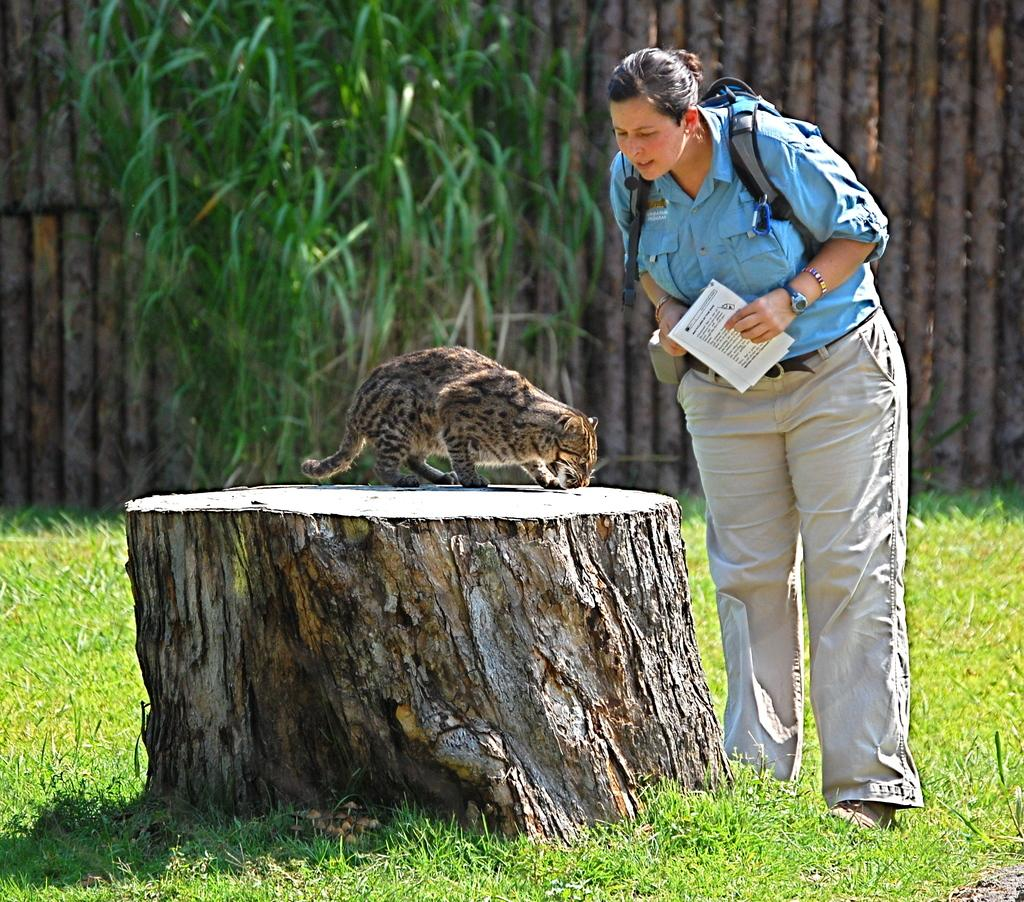What animal is on a log in the image? There is a cat on a log in the image. What is the woman doing in the image? The woman is standing on a grassland in the image. What can be seen in the background of the image? There are plants and a wooden wall in the background of the image. How far away is the stick from the cat in the image? There is no stick present in the image. 